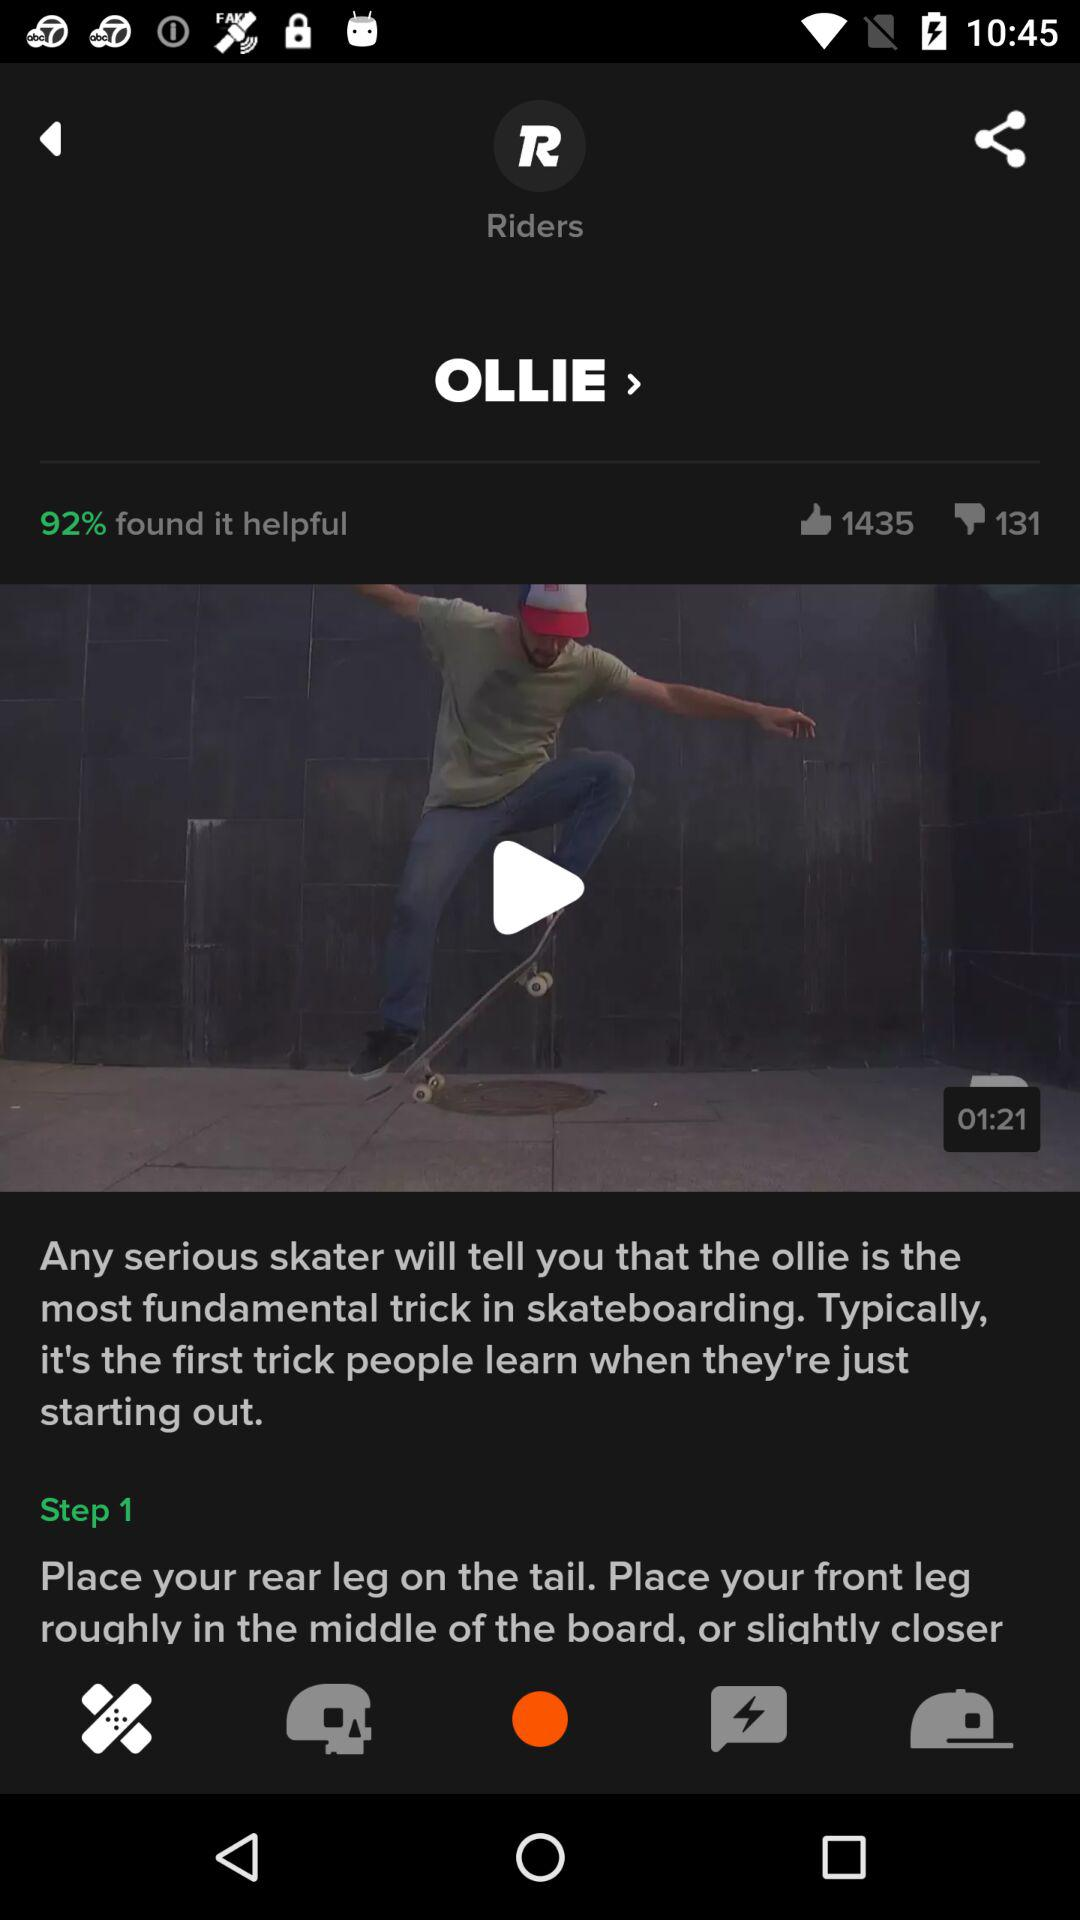What is the name of the trick? The name of the trick is "OLLIE". 